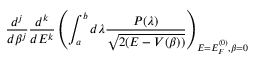<formula> <loc_0><loc_0><loc_500><loc_500>\frac { d ^ { j } } { d \beta ^ { j } } \frac { d ^ { k } } { d E ^ { k } } \left ( \int _ { a } ^ { b } d \lambda \frac { P ( \lambda ) } { \sqrt { 2 ( E - V ( \beta ) ) } } \right ) _ { E = E _ { F } ^ { ( 0 ) } , \beta = 0 }</formula> 